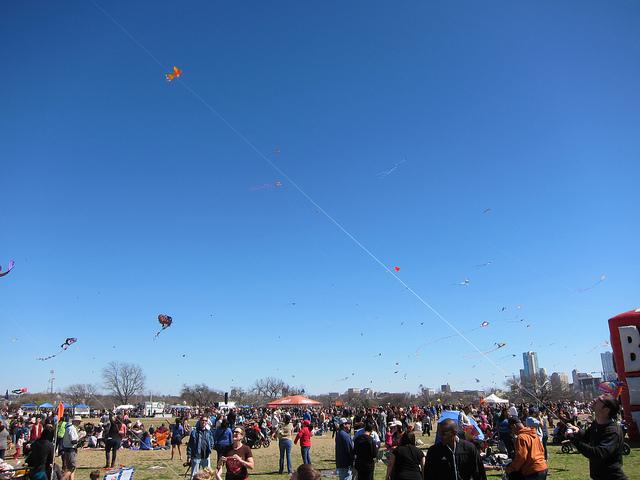What are the people spectating?
Be succinct. Kites. Is this a bikers' meeting?
Concise answer only. No. Is the sky hazy?
Concise answer only. No. What letter is in the bottom right corner?
Concise answer only. B. Where is the carousel?
Answer briefly. Nowhere. Overcast or sunny?
Short answer required. Sunny. What is happening in the background?
Give a very brief answer. Kite flying. Are there clouds out?
Answer briefly. No. Is it cloudy?
Quick response, please. No. Are there clouds?
Be succinct. No. Are there clouds in this blue sky?
Concise answer only. No. Where are these people relaxing?
Write a very short answer. Park. Is this a cloudy day?
Short answer required. No. How many umbrellas are there?
Answer briefly. 5. How many umbrellas are in this picture?
Keep it brief. 0. How many people are there?
Short answer required. 200. Is the sky cloudy?
Quick response, please. No. Is the picture colorful?
Keep it brief. Yes. Are the mountains in the background?
Write a very short answer. No. Are the clouds visible?
Be succinct. No. What is the gender of the individual in the photo?
Be succinct. Male. Are there clouds in the photo?
Give a very brief answer. No. What time of day is this?
Be succinct. Afternoon. Is the closet kite that is seen flying higher than the other kites?
Keep it brief. Yes. Does it look like it might rain?
Be succinct. No. What are in the sky?
Short answer required. Kites. 